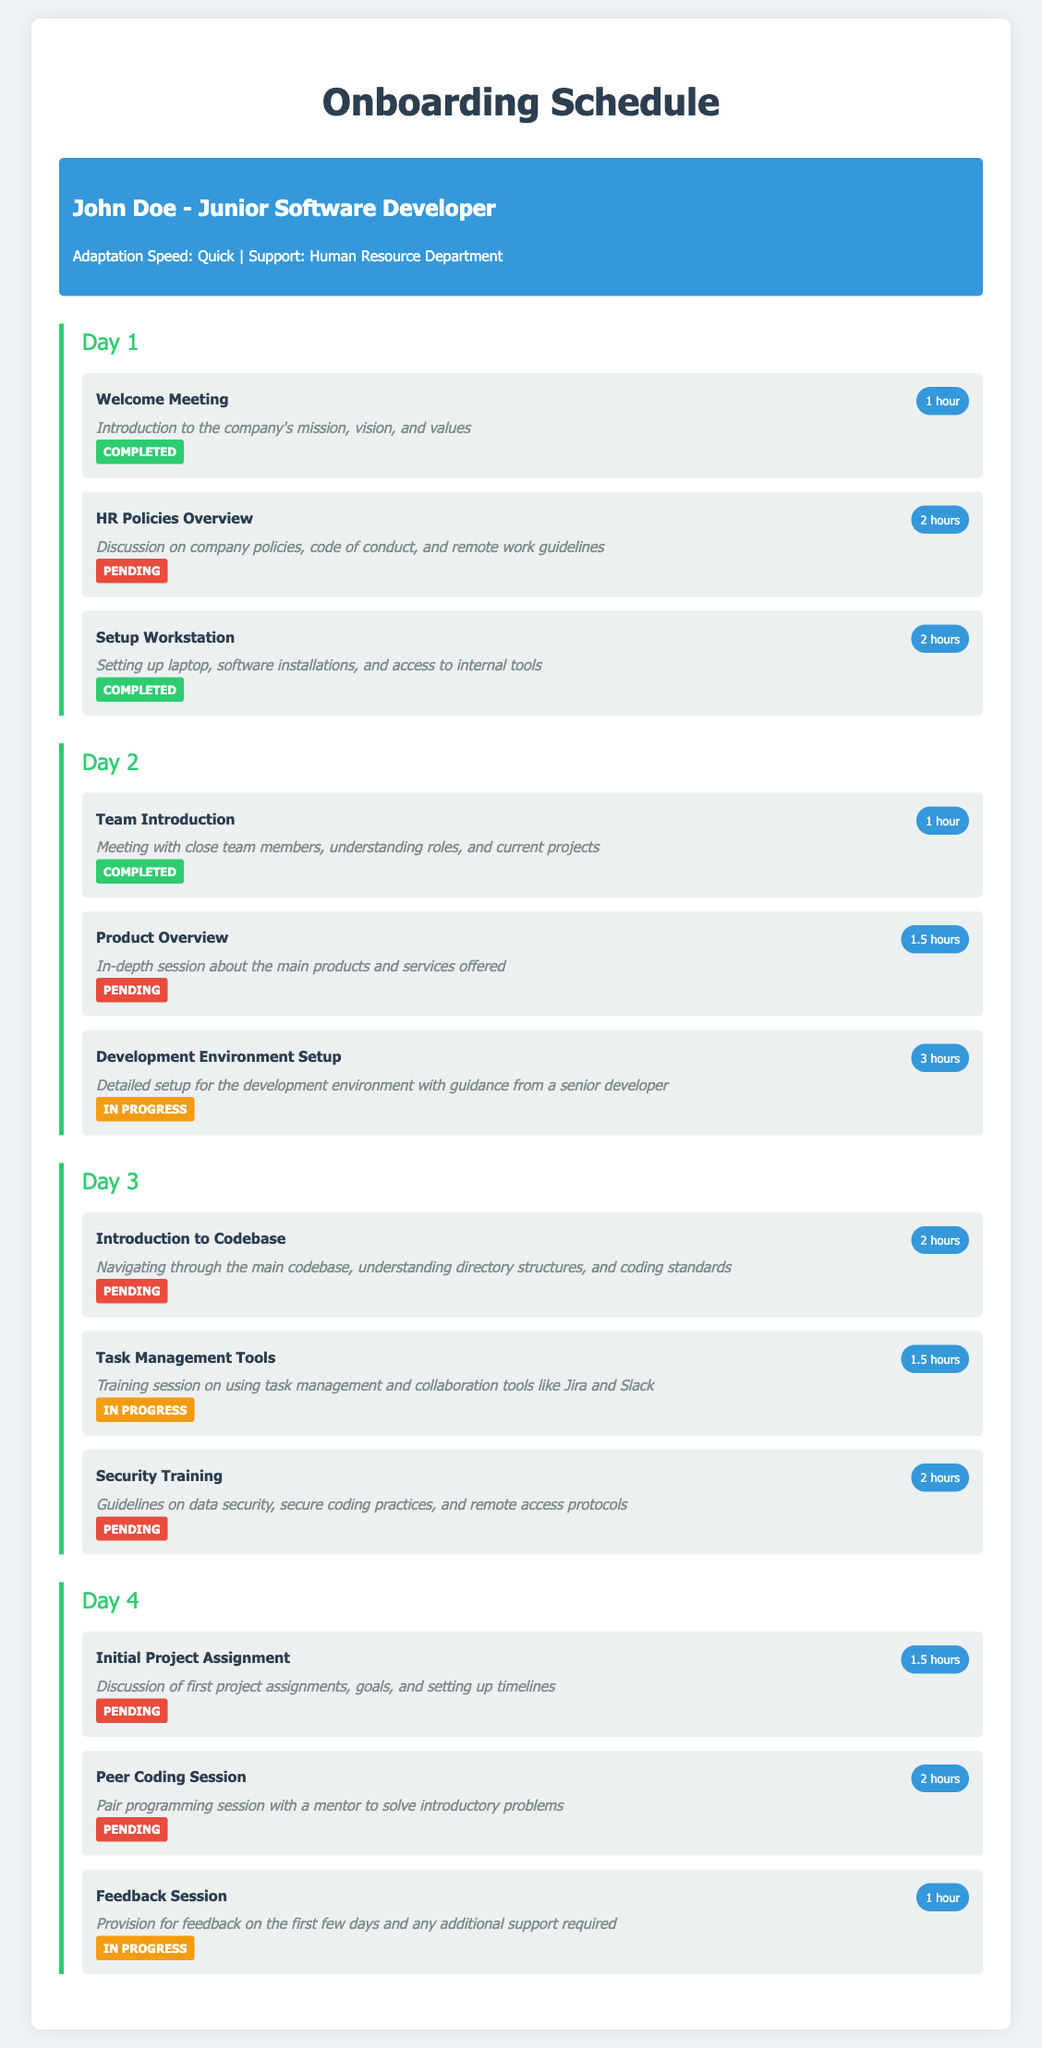What is the name of the employee? The employee's name is displayed at the top of the document under employee info.
Answer: John Doe How many hours is the setup workstation session? The duration of the setup workstation session is shown next to the session details.
Answer: 2 hours Which session is still in progress on Day 4? By reviewing the completion statuses, we can determine which session has the status of "In Progress."
Answer: Feedback Session What is the completion status of the HR Policies Overview? The completion status is listed with each session, allowing for a clear identification of its current status.
Answer: Pending How many sessions are there in total planned for Day 2? The number of sessions is the sum of all individual sessions listed under Day 2.
Answer: 3 sessions What is the duration of the Introduction to Codebase session? The session duration is provided within the session details.
Answer: 2 hours Which day includes the session on Security Training? By looking at the section headings for each day, we can identify where the session is listed.
Answer: Day 3 How many sessions have been completed by Day 1? The question involves counting the sessions with a "Completed" status under Day 1.
Answer: 2 sessions What type of training is discussed for Day 3? The types of training sessions can be identified by reviewing the session titles listed for Day 3.
Answer: Task Management Tools 